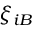<formula> <loc_0><loc_0><loc_500><loc_500>\xi _ { i B }</formula> 